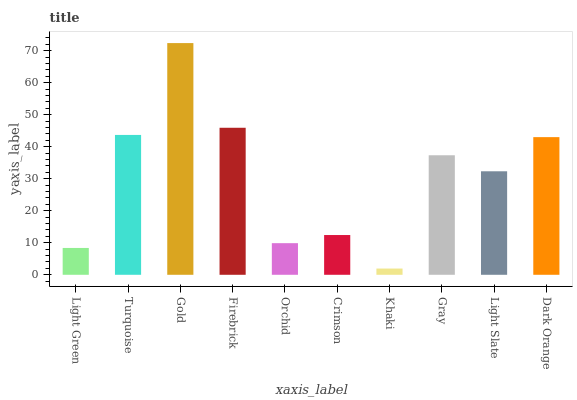Is Turquoise the minimum?
Answer yes or no. No. Is Turquoise the maximum?
Answer yes or no. No. Is Turquoise greater than Light Green?
Answer yes or no. Yes. Is Light Green less than Turquoise?
Answer yes or no. Yes. Is Light Green greater than Turquoise?
Answer yes or no. No. Is Turquoise less than Light Green?
Answer yes or no. No. Is Gray the high median?
Answer yes or no. Yes. Is Light Slate the low median?
Answer yes or no. Yes. Is Light Slate the high median?
Answer yes or no. No. Is Turquoise the low median?
Answer yes or no. No. 